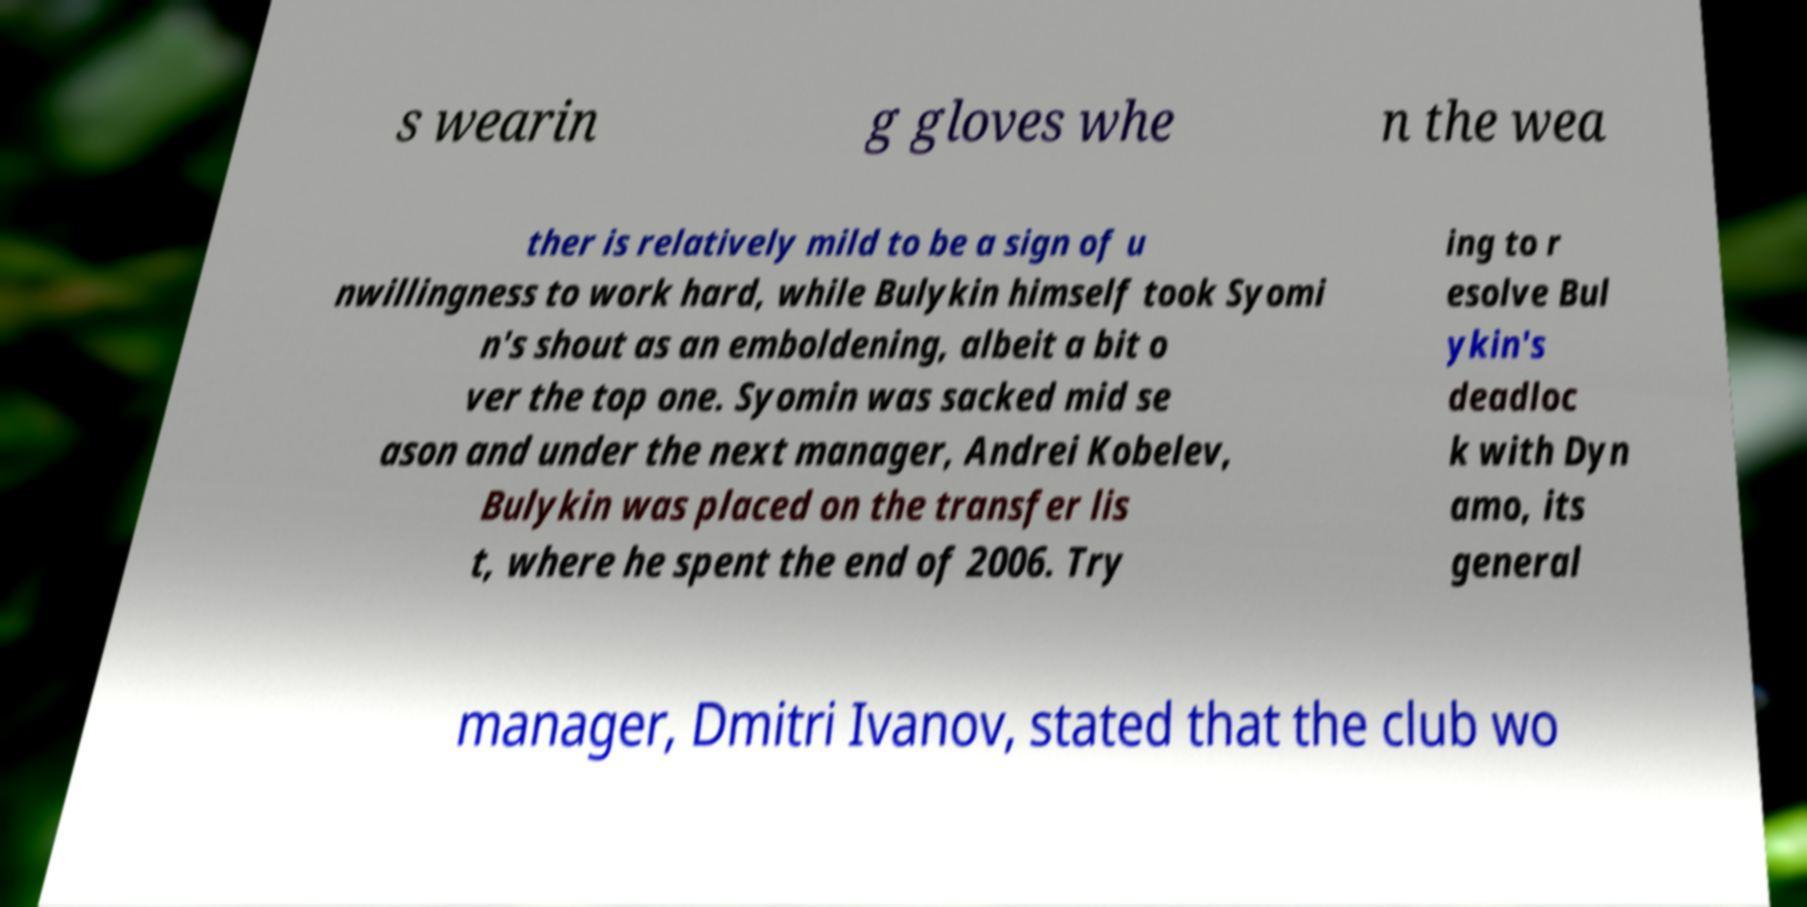For documentation purposes, I need the text within this image transcribed. Could you provide that? s wearin g gloves whe n the wea ther is relatively mild to be a sign of u nwillingness to work hard, while Bulykin himself took Syomi n's shout as an emboldening, albeit a bit o ver the top one. Syomin was sacked mid se ason and under the next manager, Andrei Kobelev, Bulykin was placed on the transfer lis t, where he spent the end of 2006. Try ing to r esolve Bul ykin's deadloc k with Dyn amo, its general manager, Dmitri Ivanov, stated that the club wo 